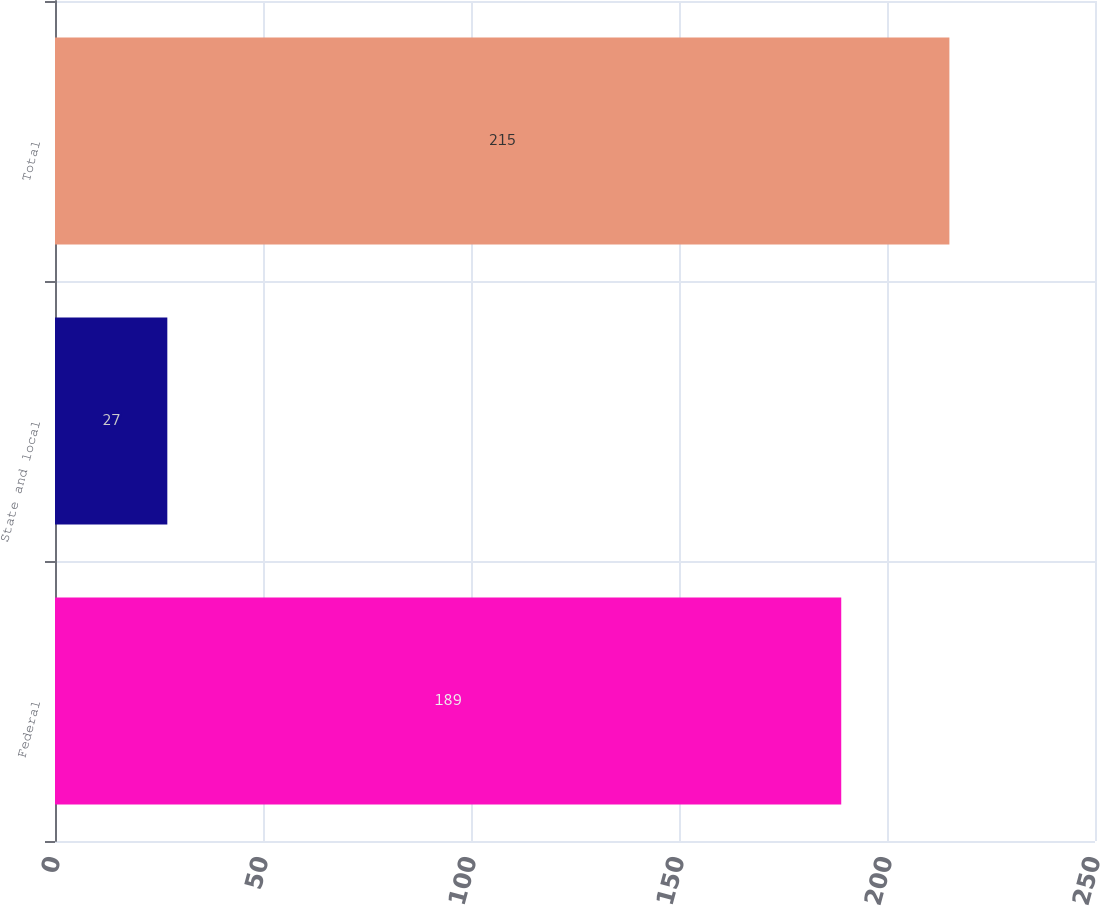Convert chart to OTSL. <chart><loc_0><loc_0><loc_500><loc_500><bar_chart><fcel>Federal<fcel>State and local<fcel>Total<nl><fcel>189<fcel>27<fcel>215<nl></chart> 